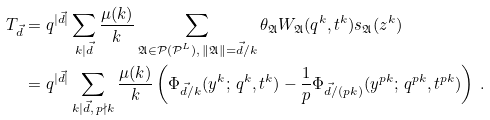<formula> <loc_0><loc_0><loc_500><loc_500>T _ { \vec { d } } & = q ^ { | \vec { d } | } \sum _ { k | \vec { d } } \frac { \mu ( k ) } { k } \sum _ { \mathfrak { A } \in \mathcal { P ( P } ^ { L } ) , \, \| \mathfrak { A } \| = \vec { d } / k } \theta _ { \mathfrak { A } } W _ { \mathfrak { A } } ( q ^ { k } , t ^ { k } ) s _ { \mathfrak { A } } ( z ^ { k } ) \\ & = q ^ { | \vec { d } | } \sum _ { k | \vec { d } , \, p \nmid k } \frac { \mu ( k ) } { k } \left ( \Phi _ { \vec { d } / k } ( y ^ { k } ; \, q ^ { k } , t ^ { k } ) - \frac { 1 } { p } \Phi _ { \vec { d } / ( p k ) } ( y ^ { p k } ; \, q ^ { p k } , t ^ { p k } ) \right ) \, .</formula> 